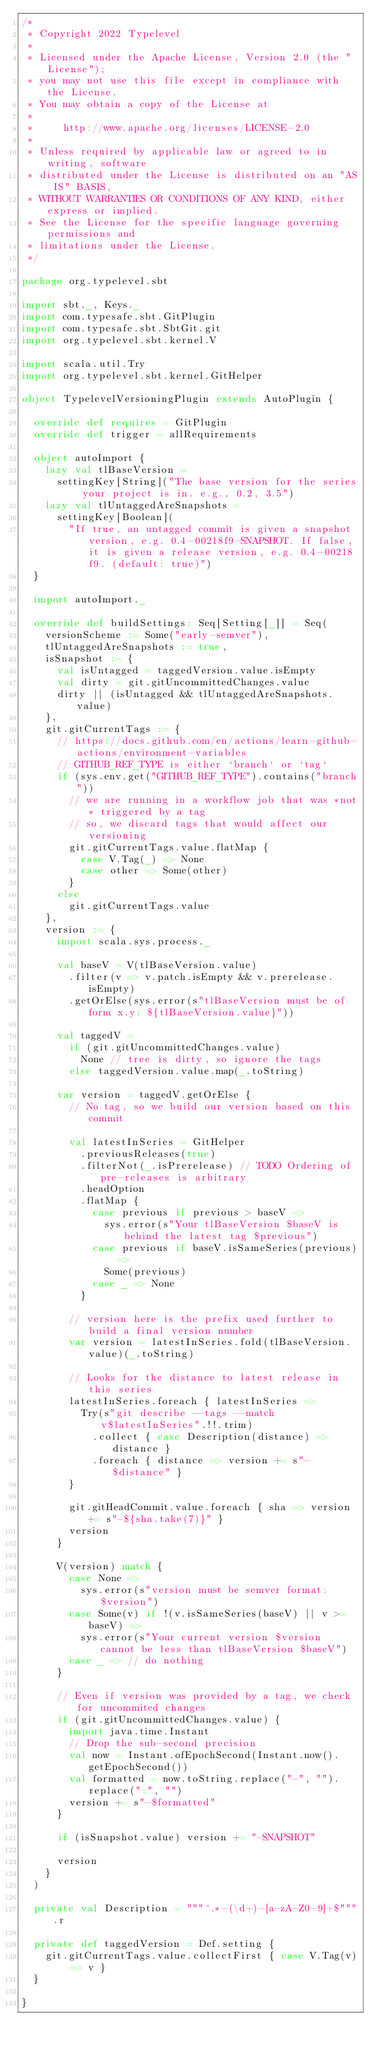<code> <loc_0><loc_0><loc_500><loc_500><_Scala_>/*
 * Copyright 2022 Typelevel
 *
 * Licensed under the Apache License, Version 2.0 (the "License");
 * you may not use this file except in compliance with the License.
 * You may obtain a copy of the License at
 *
 *     http://www.apache.org/licenses/LICENSE-2.0
 *
 * Unless required by applicable law or agreed to in writing, software
 * distributed under the License is distributed on an "AS IS" BASIS,
 * WITHOUT WARRANTIES OR CONDITIONS OF ANY KIND, either express or implied.
 * See the License for the specific language governing permissions and
 * limitations under the License.
 */

package org.typelevel.sbt

import sbt._, Keys._
import com.typesafe.sbt.GitPlugin
import com.typesafe.sbt.SbtGit.git
import org.typelevel.sbt.kernel.V

import scala.util.Try
import org.typelevel.sbt.kernel.GitHelper

object TypelevelVersioningPlugin extends AutoPlugin {

  override def requires = GitPlugin
  override def trigger = allRequirements

  object autoImport {
    lazy val tlBaseVersion =
      settingKey[String]("The base version for the series your project is in. e.g., 0.2, 3.5")
    lazy val tlUntaggedAreSnapshots =
      settingKey[Boolean](
        "If true, an untagged commit is given a snapshot version, e.g. 0.4-00218f9-SNAPSHOT. If false, it is given a release version, e.g. 0.4-00218f9. (default: true)")
  }

  import autoImport._

  override def buildSettings: Seq[Setting[_]] = Seq(
    versionScheme := Some("early-semver"),
    tlUntaggedAreSnapshots := true,
    isSnapshot := {
      val isUntagged = taggedVersion.value.isEmpty
      val dirty = git.gitUncommittedChanges.value
      dirty || (isUntagged && tlUntaggedAreSnapshots.value)
    },
    git.gitCurrentTags := {
      // https://docs.github.com/en/actions/learn-github-actions/environment-variables
      // GITHUB_REF_TYPE is either `branch` or `tag`
      if (sys.env.get("GITHUB_REF_TYPE").contains("branch"))
        // we are running in a workflow job that was *not* triggered by a tag
        // so, we discard tags that would affect our versioning
        git.gitCurrentTags.value.flatMap {
          case V.Tag(_) => None
          case other => Some(other)
        }
      else
        git.gitCurrentTags.value
    },
    version := {
      import scala.sys.process._

      val baseV = V(tlBaseVersion.value)
        .filter(v => v.patch.isEmpty && v.prerelease.isEmpty)
        .getOrElse(sys.error(s"tlBaseVersion must be of form x.y: ${tlBaseVersion.value}"))

      val taggedV =
        if (git.gitUncommittedChanges.value)
          None // tree is dirty, so ignore the tags
        else taggedVersion.value.map(_.toString)

      var version = taggedV.getOrElse {
        // No tag, so we build our version based on this commit

        val latestInSeries = GitHelper
          .previousReleases(true)
          .filterNot(_.isPrerelease) // TODO Ordering of pre-releases is arbitrary
          .headOption
          .flatMap {
            case previous if previous > baseV =>
              sys.error(s"Your tlBaseVersion $baseV is behind the latest tag $previous")
            case previous if baseV.isSameSeries(previous) =>
              Some(previous)
            case _ => None
          }

        // version here is the prefix used further to build a final version number
        var version = latestInSeries.fold(tlBaseVersion.value)(_.toString)

        // Looks for the distance to latest release in this series
        latestInSeries.foreach { latestInSeries =>
          Try(s"git describe --tags --match v$latestInSeries".!!.trim)
            .collect { case Description(distance) => distance }
            .foreach { distance => version += s"-$distance" }
        }

        git.gitHeadCommit.value.foreach { sha => version += s"-${sha.take(7)}" }
        version
      }

      V(version) match {
        case None =>
          sys.error(s"version must be semver format: $version")
        case Some(v) if !(v.isSameSeries(baseV) || v >= baseV) =>
          sys.error(s"Your current version $version cannot be less than tlBaseVersion $baseV")
        case _ => // do nothing
      }

      // Even if version was provided by a tag, we check for uncommited changes
      if (git.gitUncommittedChanges.value) {
        import java.time.Instant
        // Drop the sub-second precision
        val now = Instant.ofEpochSecond(Instant.now().getEpochSecond())
        val formatted = now.toString.replace("-", "").replace(":", "")
        version += s"-$formatted"
      }

      if (isSnapshot.value) version += "-SNAPSHOT"

      version
    }
  )

  private val Description = """^.*-(\d+)-[a-zA-Z0-9]+$""".r

  private def taggedVersion = Def.setting {
    git.gitCurrentTags.value.collectFirst { case V.Tag(v) => v }
  }

}
</code> 